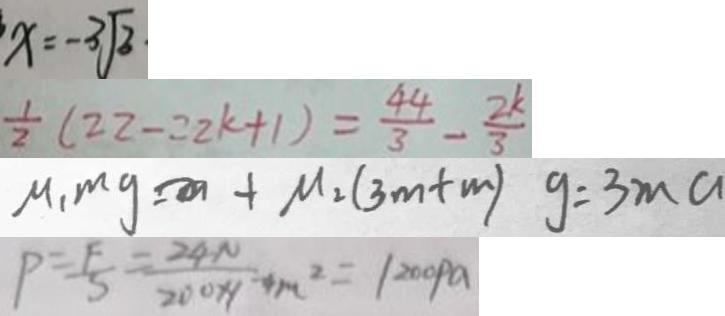<formula> <loc_0><loc_0><loc_500><loc_500>x = - 3 \sqrt { 3 } 
 \frac { 1 } { 2 } ( 2 2 - 2 2 k + 1 ) = \frac { 4 4 } { 3 } - \frac { 2 k } { 3 } 
 M _ { 1 } m g = M _ { 2 } ( 3 m + m ) g = 3 m a 
 P = \frac { F } { S } = \frac { 2 4 N } { 2 0 0 \times 1 } - 4 m ^ { 2 } = 1 2 0 0 P a</formula> 